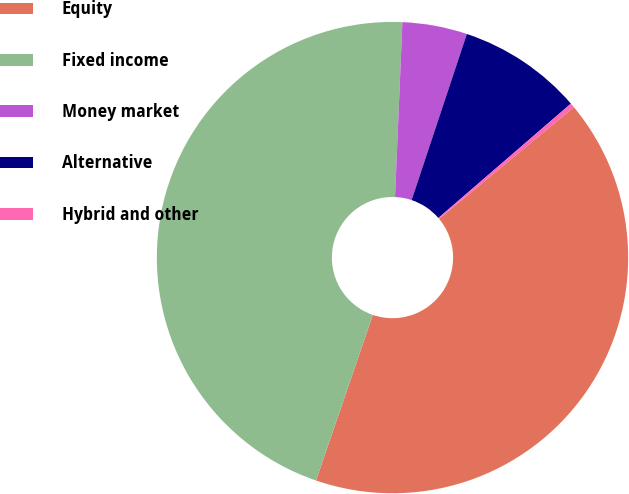Convert chart. <chart><loc_0><loc_0><loc_500><loc_500><pie_chart><fcel>Equity<fcel>Fixed income<fcel>Money market<fcel>Alternative<fcel>Hybrid and other<nl><fcel>41.28%<fcel>45.41%<fcel>4.44%<fcel>8.56%<fcel>0.31%<nl></chart> 